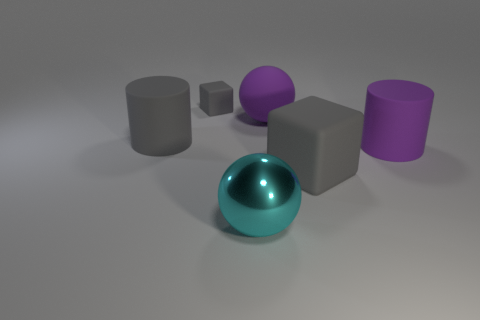There is a large cylinder right of the gray matte block that is to the left of the cyan shiny object; how many large cyan spheres are to the right of it?
Your answer should be very brief. 0. Is the number of large yellow matte spheres less than the number of large objects?
Provide a succinct answer. Yes. Does the matte object that is left of the tiny gray cube have the same shape as the gray thing that is on the right side of the tiny gray matte block?
Offer a very short reply. No. The large shiny sphere has what color?
Provide a succinct answer. Cyan. What number of metal things are either large purple cubes or gray objects?
Offer a very short reply. 0. The other thing that is the same shape as the small gray rubber object is what color?
Keep it short and to the point. Gray. Are any gray matte objects visible?
Offer a terse response. Yes. Is the large object to the right of the big gray matte block made of the same material as the large object left of the small thing?
Your answer should be compact. Yes. There is a big rubber thing that is the same color as the rubber ball; what is its shape?
Provide a short and direct response. Cylinder. How many things are either cylinders on the right side of the large block or things that are on the left side of the big cyan shiny ball?
Your answer should be very brief. 3. 